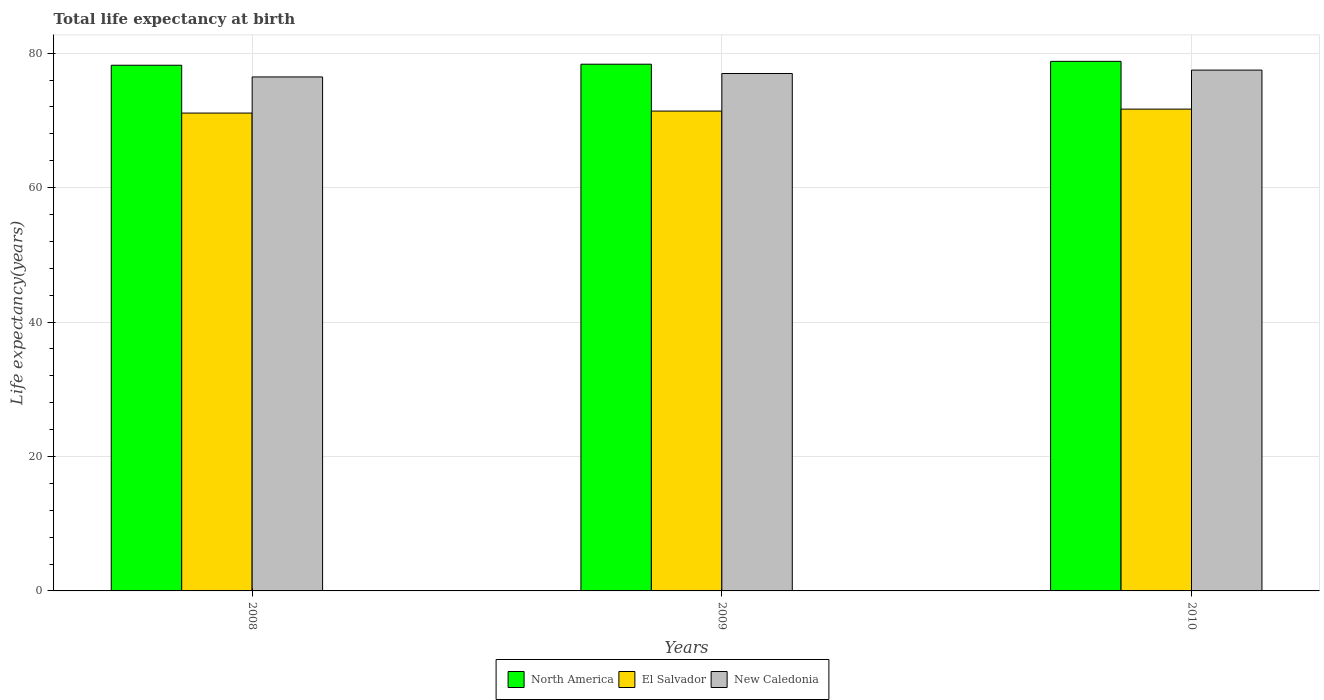How many different coloured bars are there?
Provide a succinct answer. 3. How many groups of bars are there?
Your response must be concise. 3. Are the number of bars per tick equal to the number of legend labels?
Provide a short and direct response. Yes. How many bars are there on the 3rd tick from the right?
Make the answer very short. 3. What is the label of the 1st group of bars from the left?
Offer a terse response. 2008. What is the life expectancy at birth in in El Salvador in 2008?
Your answer should be compact. 71.08. Across all years, what is the maximum life expectancy at birth in in El Salvador?
Provide a short and direct response. 71.67. Across all years, what is the minimum life expectancy at birth in in New Caledonia?
Provide a short and direct response. 76.46. In which year was the life expectancy at birth in in El Salvador minimum?
Make the answer very short. 2008. What is the total life expectancy at birth in in El Salvador in the graph?
Keep it short and to the point. 214.13. What is the difference between the life expectancy at birth in in New Caledonia in 2008 and that in 2010?
Make the answer very short. -1.02. What is the difference between the life expectancy at birth in in El Salvador in 2010 and the life expectancy at birth in in North America in 2009?
Your response must be concise. -6.68. What is the average life expectancy at birth in in El Salvador per year?
Provide a short and direct response. 71.38. In the year 2009, what is the difference between the life expectancy at birth in in New Caledonia and life expectancy at birth in in El Salvador?
Provide a succinct answer. 5.59. What is the ratio of the life expectancy at birth in in El Salvador in 2009 to that in 2010?
Keep it short and to the point. 1. What is the difference between the highest and the second highest life expectancy at birth in in El Salvador?
Give a very brief answer. 0.29. What is the difference between the highest and the lowest life expectancy at birth in in North America?
Your answer should be compact. 0.58. In how many years, is the life expectancy at birth in in El Salvador greater than the average life expectancy at birth in in El Salvador taken over all years?
Make the answer very short. 2. Is the sum of the life expectancy at birth in in North America in 2008 and 2009 greater than the maximum life expectancy at birth in in New Caledonia across all years?
Offer a very short reply. Yes. What does the 2nd bar from the right in 2010 represents?
Offer a very short reply. El Salvador. What is the difference between two consecutive major ticks on the Y-axis?
Your answer should be very brief. 20. Does the graph contain any zero values?
Provide a short and direct response. No. How are the legend labels stacked?
Offer a very short reply. Horizontal. What is the title of the graph?
Keep it short and to the point. Total life expectancy at birth. What is the label or title of the X-axis?
Provide a succinct answer. Years. What is the label or title of the Y-axis?
Your response must be concise. Life expectancy(years). What is the Life expectancy(years) of North America in 2008?
Ensure brevity in your answer.  78.2. What is the Life expectancy(years) in El Salvador in 2008?
Offer a terse response. 71.08. What is the Life expectancy(years) of New Caledonia in 2008?
Your answer should be compact. 76.46. What is the Life expectancy(years) in North America in 2009?
Your response must be concise. 78.35. What is the Life expectancy(years) in El Salvador in 2009?
Provide a short and direct response. 71.38. What is the Life expectancy(years) in New Caledonia in 2009?
Keep it short and to the point. 76.97. What is the Life expectancy(years) of North America in 2010?
Your answer should be compact. 78.77. What is the Life expectancy(years) in El Salvador in 2010?
Offer a terse response. 71.67. What is the Life expectancy(years) in New Caledonia in 2010?
Ensure brevity in your answer.  77.47. Across all years, what is the maximum Life expectancy(years) of North America?
Offer a very short reply. 78.77. Across all years, what is the maximum Life expectancy(years) of El Salvador?
Ensure brevity in your answer.  71.67. Across all years, what is the maximum Life expectancy(years) of New Caledonia?
Offer a terse response. 77.47. Across all years, what is the minimum Life expectancy(years) in North America?
Your answer should be very brief. 78.2. Across all years, what is the minimum Life expectancy(years) of El Salvador?
Make the answer very short. 71.08. Across all years, what is the minimum Life expectancy(years) of New Caledonia?
Your answer should be very brief. 76.46. What is the total Life expectancy(years) of North America in the graph?
Offer a terse response. 235.32. What is the total Life expectancy(years) of El Salvador in the graph?
Your answer should be compact. 214.13. What is the total Life expectancy(years) of New Caledonia in the graph?
Offer a very short reply. 230.9. What is the difference between the Life expectancy(years) of North America in 2008 and that in 2009?
Give a very brief answer. -0.15. What is the difference between the Life expectancy(years) in El Salvador in 2008 and that in 2009?
Ensure brevity in your answer.  -0.3. What is the difference between the Life expectancy(years) of New Caledonia in 2008 and that in 2009?
Provide a short and direct response. -0.51. What is the difference between the Life expectancy(years) of North America in 2008 and that in 2010?
Your response must be concise. -0.58. What is the difference between the Life expectancy(years) in El Salvador in 2008 and that in 2010?
Give a very brief answer. -0.59. What is the difference between the Life expectancy(years) of New Caledonia in 2008 and that in 2010?
Your answer should be very brief. -1.02. What is the difference between the Life expectancy(years) of North America in 2009 and that in 2010?
Offer a very short reply. -0.42. What is the difference between the Life expectancy(years) of El Salvador in 2009 and that in 2010?
Ensure brevity in your answer.  -0.29. What is the difference between the Life expectancy(years) in New Caledonia in 2009 and that in 2010?
Provide a short and direct response. -0.51. What is the difference between the Life expectancy(years) in North America in 2008 and the Life expectancy(years) in El Salvador in 2009?
Make the answer very short. 6.82. What is the difference between the Life expectancy(years) of North America in 2008 and the Life expectancy(years) of New Caledonia in 2009?
Provide a short and direct response. 1.23. What is the difference between the Life expectancy(years) of El Salvador in 2008 and the Life expectancy(years) of New Caledonia in 2009?
Offer a very short reply. -5.89. What is the difference between the Life expectancy(years) of North America in 2008 and the Life expectancy(years) of El Salvador in 2010?
Provide a short and direct response. 6.53. What is the difference between the Life expectancy(years) in North America in 2008 and the Life expectancy(years) in New Caledonia in 2010?
Keep it short and to the point. 0.72. What is the difference between the Life expectancy(years) in El Salvador in 2008 and the Life expectancy(years) in New Caledonia in 2010?
Your response must be concise. -6.39. What is the difference between the Life expectancy(years) of North America in 2009 and the Life expectancy(years) of El Salvador in 2010?
Keep it short and to the point. 6.68. What is the difference between the Life expectancy(years) of North America in 2009 and the Life expectancy(years) of New Caledonia in 2010?
Your answer should be compact. 0.88. What is the difference between the Life expectancy(years) in El Salvador in 2009 and the Life expectancy(years) in New Caledonia in 2010?
Provide a short and direct response. -6.09. What is the average Life expectancy(years) in North America per year?
Ensure brevity in your answer.  78.44. What is the average Life expectancy(years) in El Salvador per year?
Your answer should be compact. 71.38. What is the average Life expectancy(years) of New Caledonia per year?
Provide a succinct answer. 76.97. In the year 2008, what is the difference between the Life expectancy(years) of North America and Life expectancy(years) of El Salvador?
Keep it short and to the point. 7.12. In the year 2008, what is the difference between the Life expectancy(years) in North America and Life expectancy(years) in New Caledonia?
Keep it short and to the point. 1.74. In the year 2008, what is the difference between the Life expectancy(years) in El Salvador and Life expectancy(years) in New Caledonia?
Provide a succinct answer. -5.38. In the year 2009, what is the difference between the Life expectancy(years) of North America and Life expectancy(years) of El Salvador?
Ensure brevity in your answer.  6.97. In the year 2009, what is the difference between the Life expectancy(years) in North America and Life expectancy(years) in New Caledonia?
Your answer should be compact. 1.38. In the year 2009, what is the difference between the Life expectancy(years) in El Salvador and Life expectancy(years) in New Caledonia?
Provide a short and direct response. -5.59. In the year 2010, what is the difference between the Life expectancy(years) in North America and Life expectancy(years) in El Salvador?
Ensure brevity in your answer.  7.1. In the year 2010, what is the difference between the Life expectancy(years) of North America and Life expectancy(years) of New Caledonia?
Your answer should be compact. 1.3. In the year 2010, what is the difference between the Life expectancy(years) of El Salvador and Life expectancy(years) of New Caledonia?
Your answer should be very brief. -5.8. What is the ratio of the Life expectancy(years) in North America in 2008 to that in 2010?
Ensure brevity in your answer.  0.99. What is the ratio of the Life expectancy(years) in El Salvador in 2008 to that in 2010?
Your answer should be compact. 0.99. What is the ratio of the Life expectancy(years) in New Caledonia in 2008 to that in 2010?
Ensure brevity in your answer.  0.99. What is the ratio of the Life expectancy(years) in North America in 2009 to that in 2010?
Your answer should be very brief. 0.99. What is the ratio of the Life expectancy(years) of New Caledonia in 2009 to that in 2010?
Keep it short and to the point. 0.99. What is the difference between the highest and the second highest Life expectancy(years) in North America?
Offer a terse response. 0.42. What is the difference between the highest and the second highest Life expectancy(years) in El Salvador?
Offer a terse response. 0.29. What is the difference between the highest and the second highest Life expectancy(years) in New Caledonia?
Your response must be concise. 0.51. What is the difference between the highest and the lowest Life expectancy(years) in North America?
Ensure brevity in your answer.  0.58. What is the difference between the highest and the lowest Life expectancy(years) of El Salvador?
Give a very brief answer. 0.59. What is the difference between the highest and the lowest Life expectancy(years) in New Caledonia?
Your answer should be very brief. 1.02. 